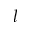<formula> <loc_0><loc_0><loc_500><loc_500>l</formula> 